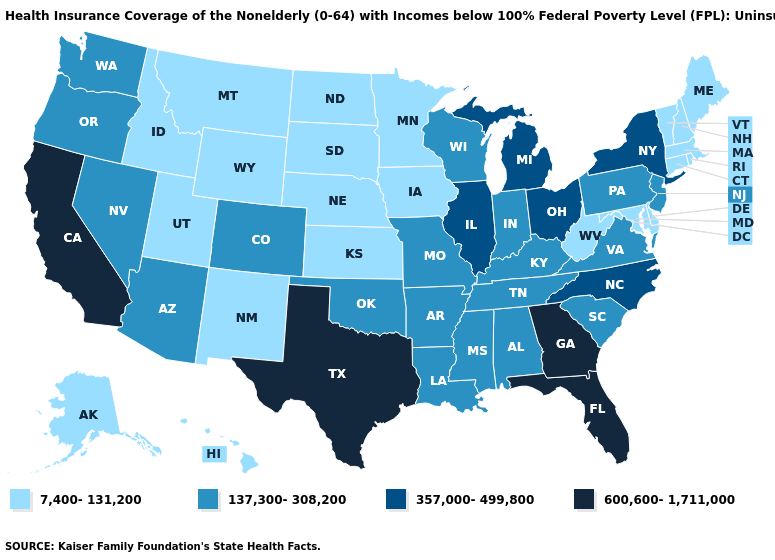What is the value of Washington?
Concise answer only. 137,300-308,200. Does Vermont have the lowest value in the USA?
Answer briefly. Yes. Does California have the lowest value in the USA?
Quick response, please. No. Does North Carolina have the lowest value in the USA?
Short answer required. No. Which states have the highest value in the USA?
Be succinct. California, Florida, Georgia, Texas. How many symbols are there in the legend?
Concise answer only. 4. Does Delaware have the highest value in the South?
Answer briefly. No. What is the lowest value in the USA?
Write a very short answer. 7,400-131,200. How many symbols are there in the legend?
Short answer required. 4. What is the value of New Jersey?
Write a very short answer. 137,300-308,200. What is the highest value in the USA?
Give a very brief answer. 600,600-1,711,000. Does Vermont have the lowest value in the Northeast?
Write a very short answer. Yes. What is the value of Hawaii?
Short answer required. 7,400-131,200. What is the value of Arkansas?
Concise answer only. 137,300-308,200. Is the legend a continuous bar?
Answer briefly. No. 